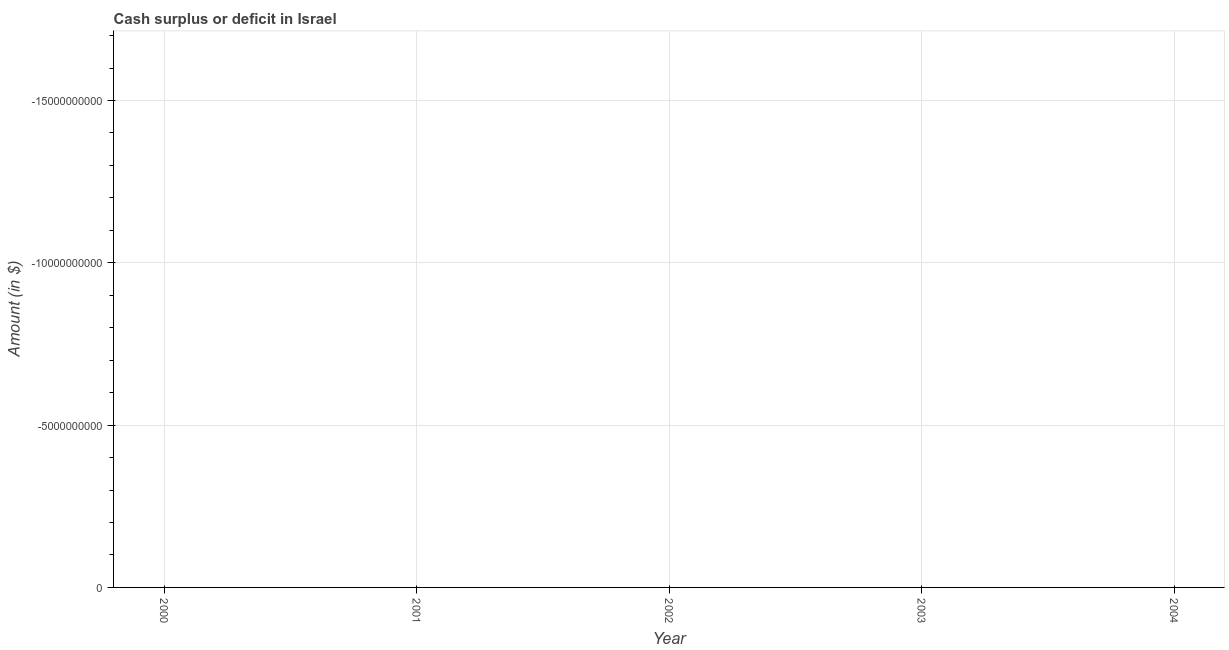What is the cash surplus or deficit in 2003?
Provide a succinct answer. 0. What is the sum of the cash surplus or deficit?
Make the answer very short. 0. What is the average cash surplus or deficit per year?
Provide a short and direct response. 0. Does the cash surplus or deficit monotonically increase over the years?
Ensure brevity in your answer.  No. Are the values on the major ticks of Y-axis written in scientific E-notation?
Give a very brief answer. No. Does the graph contain any zero values?
Your response must be concise. Yes. Does the graph contain grids?
Make the answer very short. Yes. What is the title of the graph?
Your answer should be very brief. Cash surplus or deficit in Israel. What is the label or title of the X-axis?
Your answer should be compact. Year. What is the label or title of the Y-axis?
Your response must be concise. Amount (in $). What is the Amount (in $) in 2001?
Offer a terse response. 0. What is the Amount (in $) of 2003?
Provide a succinct answer. 0. What is the Amount (in $) of 2004?
Your answer should be very brief. 0. 